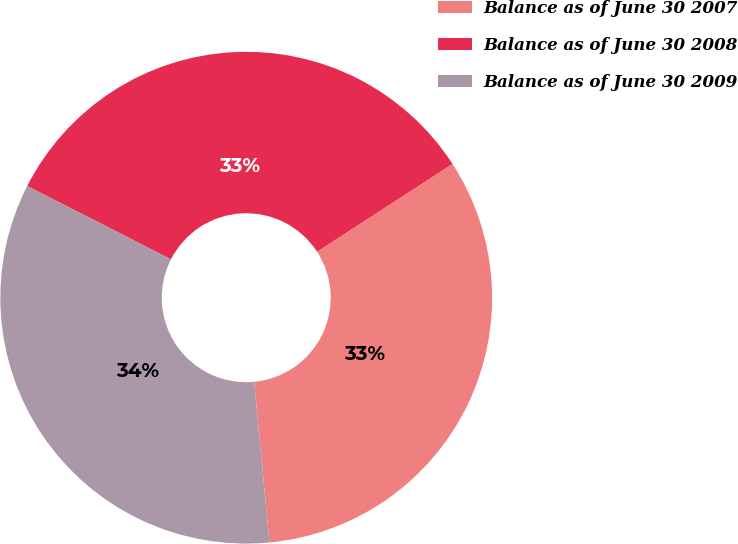Convert chart. <chart><loc_0><loc_0><loc_500><loc_500><pie_chart><fcel>Balance as of June 30 2007<fcel>Balance as of June 30 2008<fcel>Balance as of June 30 2009<nl><fcel>32.65%<fcel>33.33%<fcel>34.01%<nl></chart> 